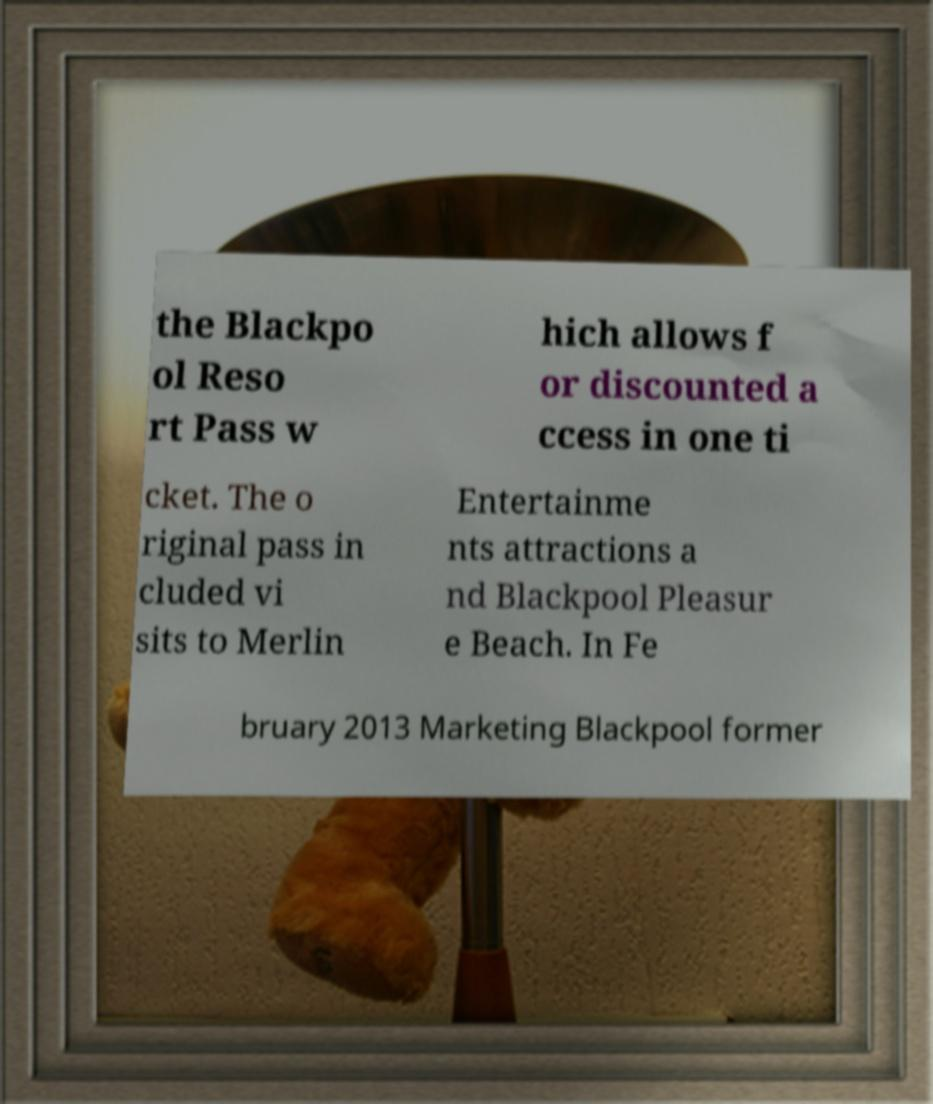Please identify and transcribe the text found in this image. the Blackpo ol Reso rt Pass w hich allows f or discounted a ccess in one ti cket. The o riginal pass in cluded vi sits to Merlin Entertainme nts attractions a nd Blackpool Pleasur e Beach. In Fe bruary 2013 Marketing Blackpool former 